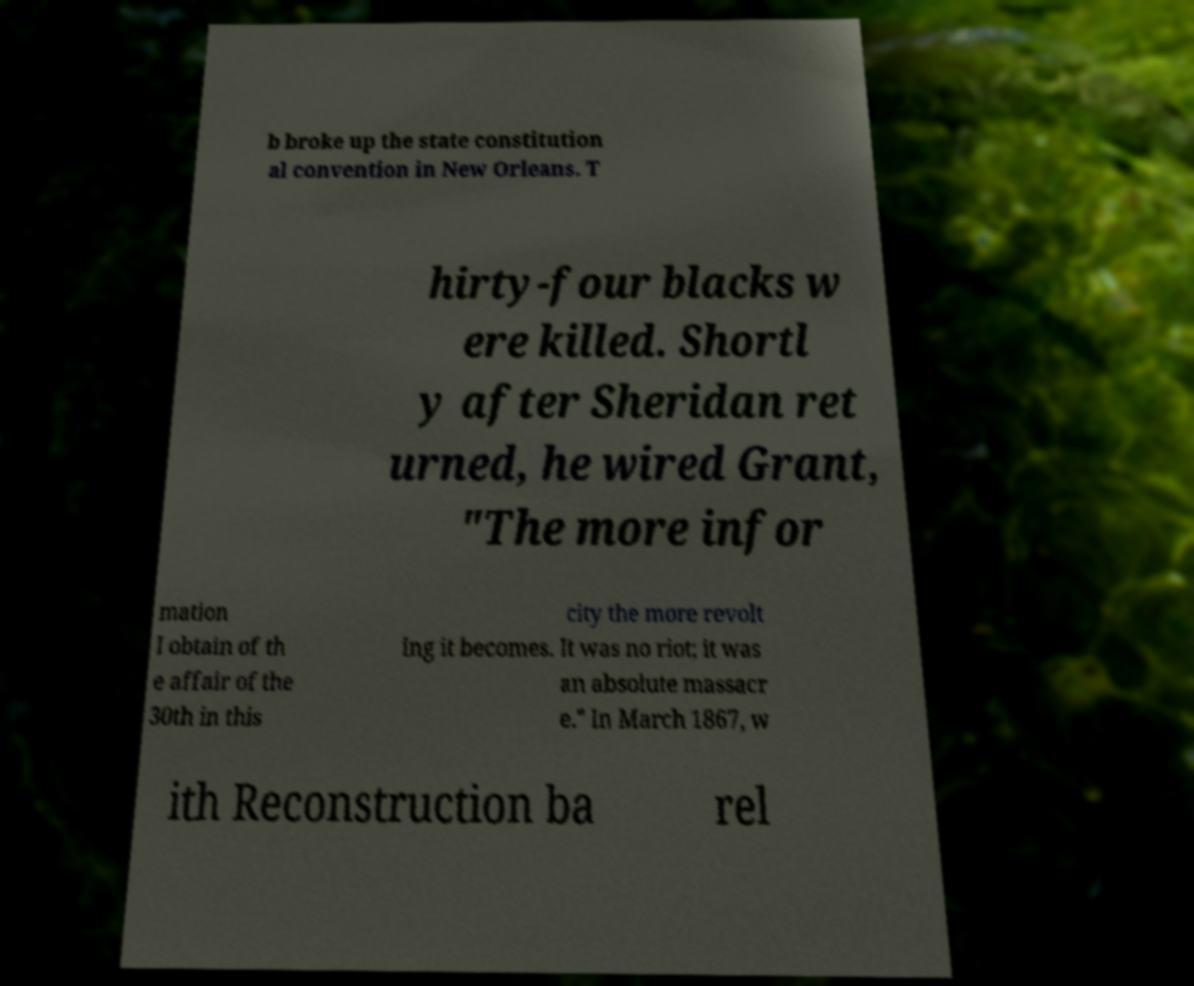Could you assist in decoding the text presented in this image and type it out clearly? b broke up the state constitution al convention in New Orleans. T hirty-four blacks w ere killed. Shortl y after Sheridan ret urned, he wired Grant, "The more infor mation I obtain of th e affair of the 30th in this city the more revolt ing it becomes. It was no riot; it was an absolute massacr e." In March 1867, w ith Reconstruction ba rel 